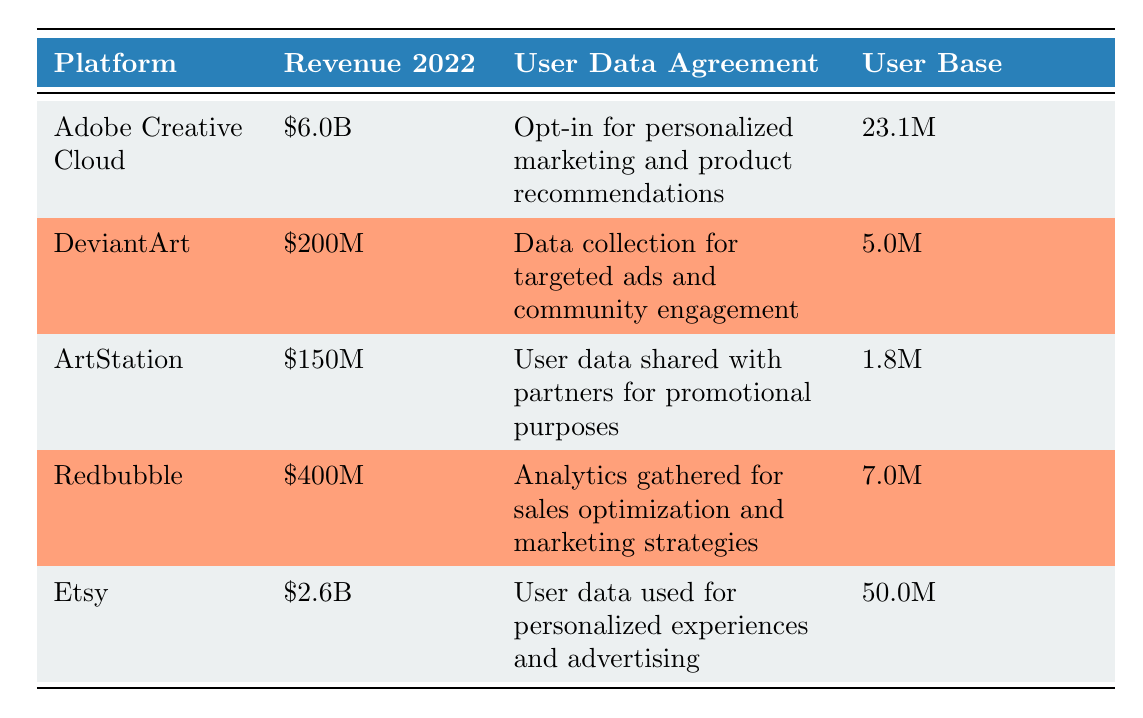What is the revenue generated by Adobe Creative Cloud in 2022? The table lists the revenue generated by Adobe Creative Cloud as \$6.0B for the year 2022.
Answer: \$6.0B Which platform has the highest number of users? According to the user base data, Etsy has the highest number of users at 50.0M, compared to the other platforms.
Answer: Etsy What is the total revenue generated by all platforms listed? The total revenue can be calculated by summing up each platform's revenue: \$6.0B + \$200M + \$150M + \$400M + \$2.6B = \$9.4B.
Answer: \$9.4B Is the user data agreement for ArtStation related to targeted advertising? The user data agreement for ArtStation states that user data is shared with partners for promotional purposes, which does not directly reference targeted advertising.
Answer: No How much revenue did Redbubble generate compared to DeviantArt? Redbubble generated \$400M, while DeviantArt generated \$200M. Therefore, Redbubble's revenue is double that of DeviantArt, calculated as \$400M - \$200M = \$200M more.
Answer: \$200M more What is the average revenue generated by the platforms with user data agreements focused on personalized experiences? The platforms with such agreements are Adobe Creative Cloud and Etsy, generating \$6.0B and \$2.6B respectively. The average is calculated as (6.0B + 2.6B) / 2 = \$4.3B.
Answer: \$4.3B Are there more users on DeviantArt or ArtStation? DeviantArt has 5.0M users and ArtStation has 1.8M users; thus, DeviantArt has more users than ArtStation.
Answer: Yes What is the difference in revenue between the platform with the highest revenue and the platform with the lowest revenue? The platform with the highest revenue is Adobe Creative Cloud with \$6.0B, and the platform with the lowest is ArtStation with \$150M. The difference is calculated as \$6.0B - \$150M = \$5.85B.
Answer: \$5.85B What percentage of the total revenue does Etsy contribute? Total revenue is \$9.4B while Etsy's revenue is \$2.6B. The percentage is calculated as (\$2.6B / \$9.4B) * 100 = approximately 27.66%.
Answer: 27.66% 